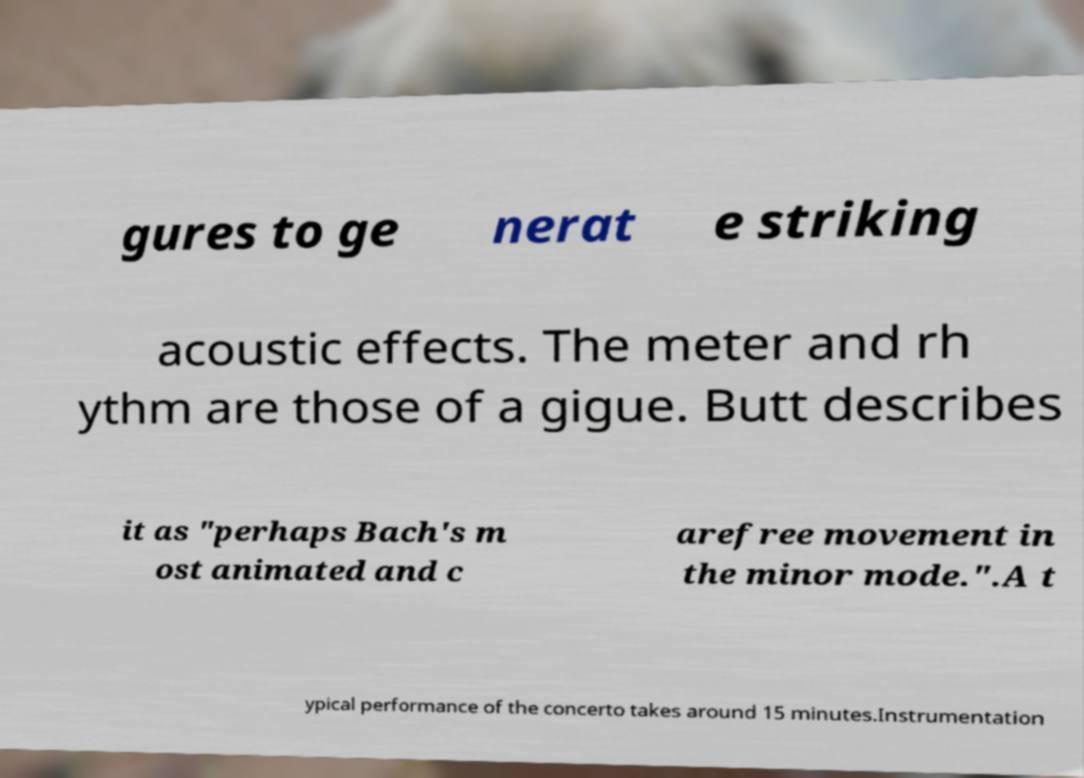There's text embedded in this image that I need extracted. Can you transcribe it verbatim? gures to ge nerat e striking acoustic effects. The meter and rh ythm are those of a gigue. Butt describes it as "perhaps Bach's m ost animated and c arefree movement in the minor mode.".A t ypical performance of the concerto takes around 15 minutes.Instrumentation 